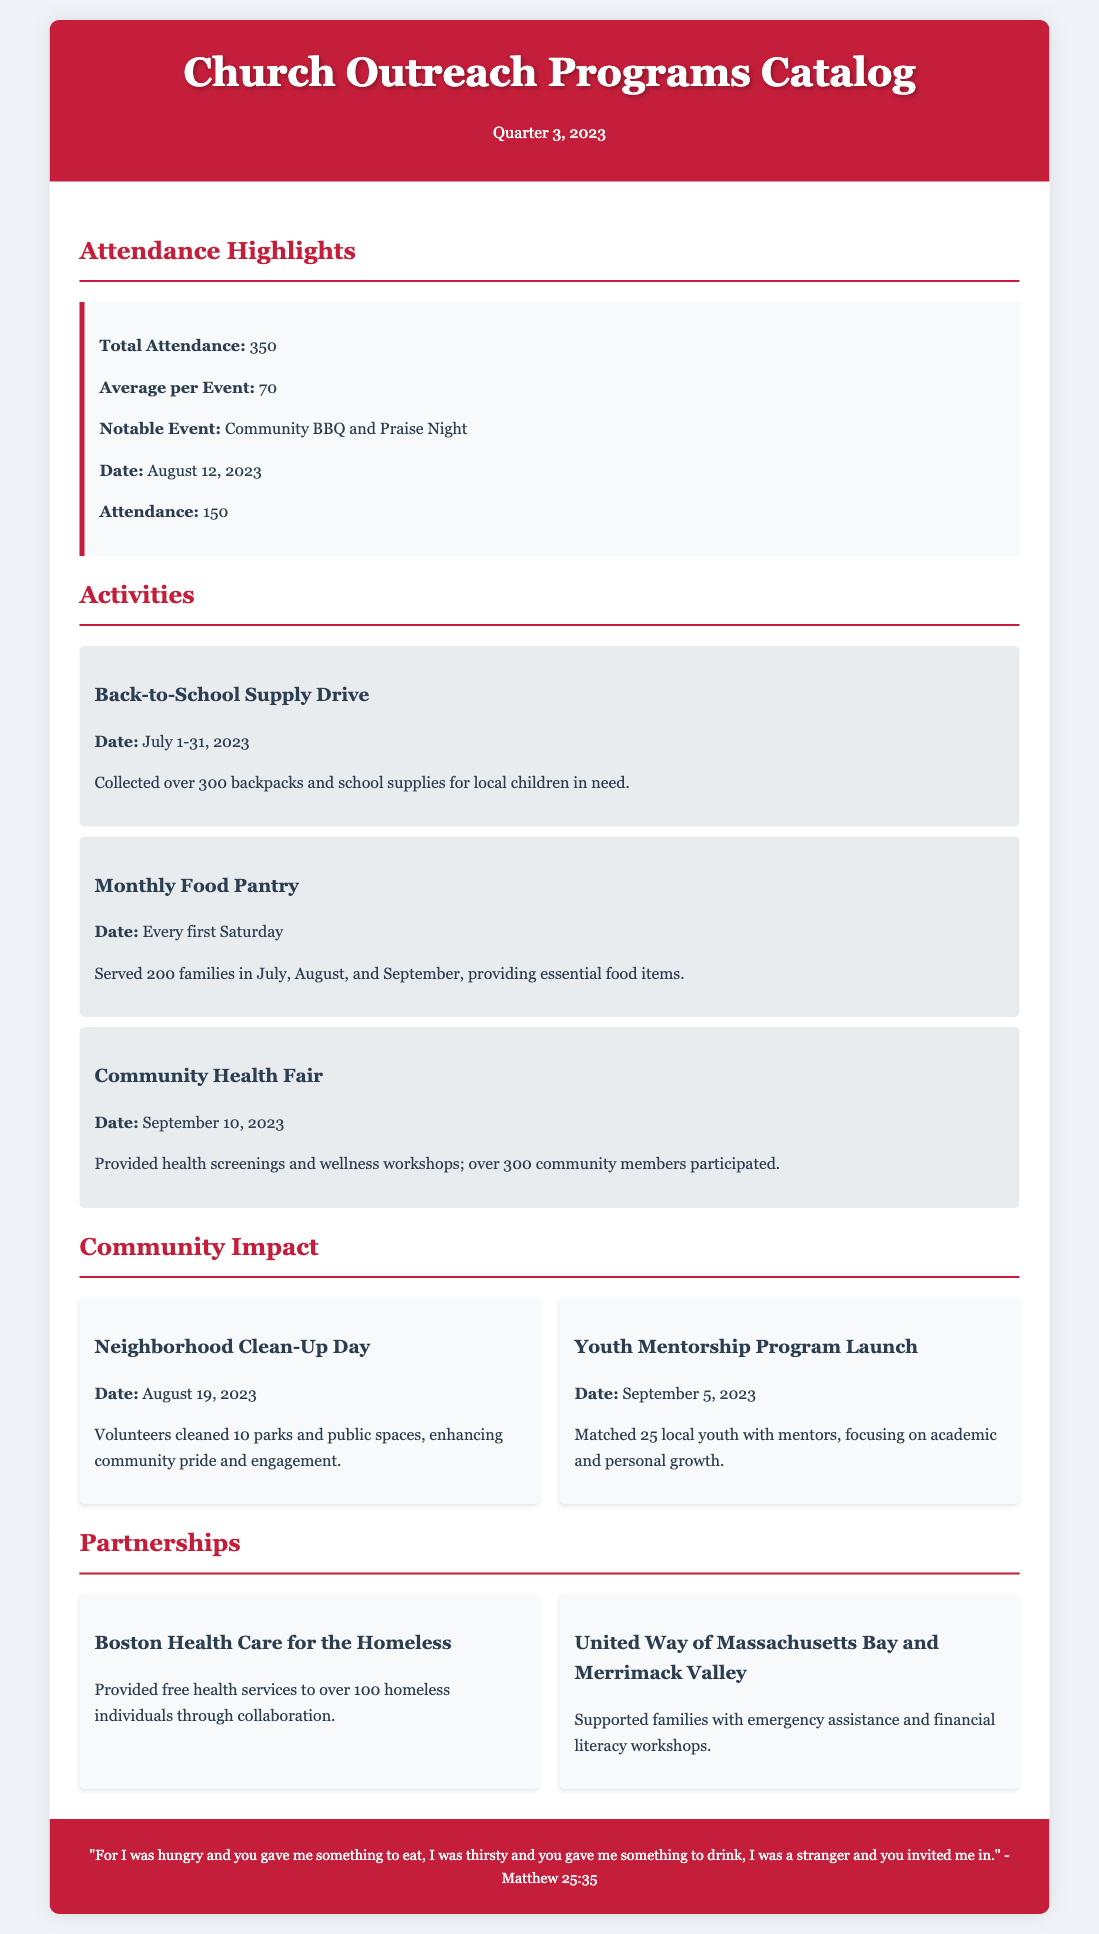what was the total attendance for the quarter? The total attendance figure is provided in the Attendance Highlights section of the document.
Answer: 350 what was the notable event and its attendance? The notable event mentioned along with its attendance is found in the Attendance Highlights section.
Answer: Community BBQ and Praise Night, 150 how many backpacks were collected in the Back-to-School Supply Drive? The number of backpacks collected is specified in the description of the activity.
Answer: over 300 which partnership provided health services to the homeless? This information can be found in the Partnerships section detailing the collaboration.
Answer: Boston Health Care for the Homeless how many families were served in the Monthly Food Pantry? The number of families served is listed in the description about this activity.
Answer: 200 families what was the date of the Community Health Fair? The date of the event is stated in the details of the activity.
Answer: September 10, 2023 how many local youth were matched with mentors in the Youth Mentorship Program? This information is provided in the description of the program's launch.
Answer: 25 what is the average attendance per event? The average attendance figure is provided in the Attendance Highlights section of the document.
Answer: 70 what significant community impact occurred on August 19, 2023? The specific community impact event is detailed in the Community Impact section.
Answer: Neighborhood Clean-Up Day 